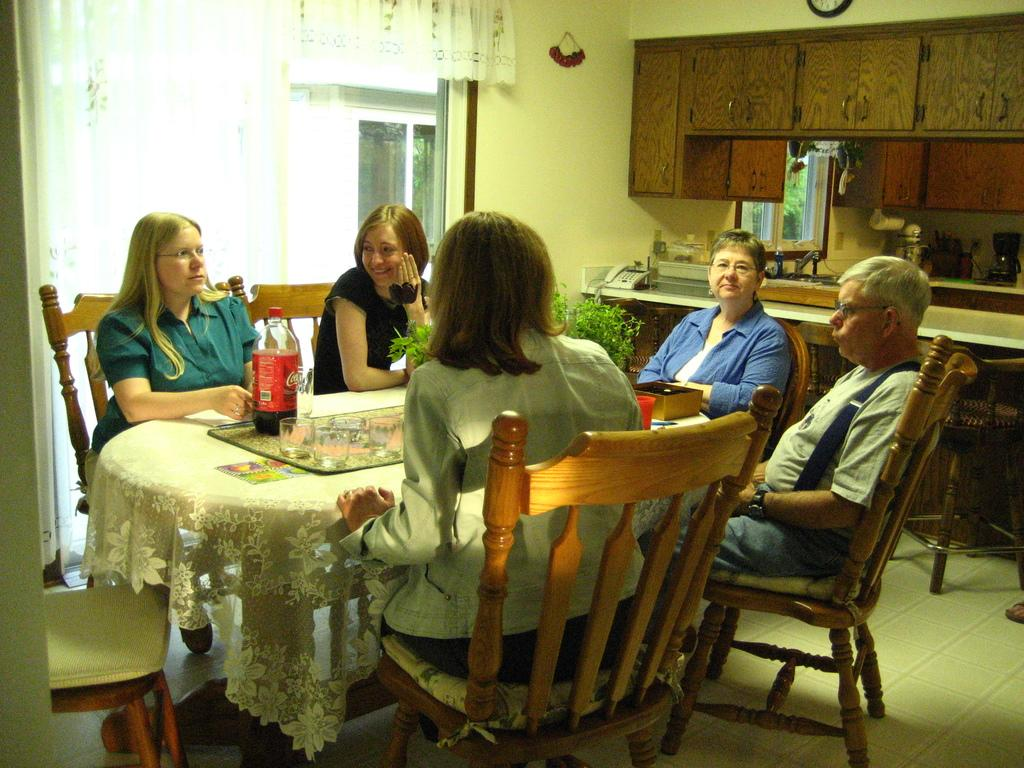How many people are sitting in the image? There are five people sitting on chairs in the image. What are the chairs arranged around? The chairs are arranged around a table. What can be found on the table? There are glasses and a coke bottle on the table. What is located near the table? There is a shelf and a small plant near the table. What type of vegetable is being used as a rod to hold up the coke bottle in the image? There is no vegetable being used as a rod to hold up the coke bottle in the image; the coke bottle is simply sitting on the table. 